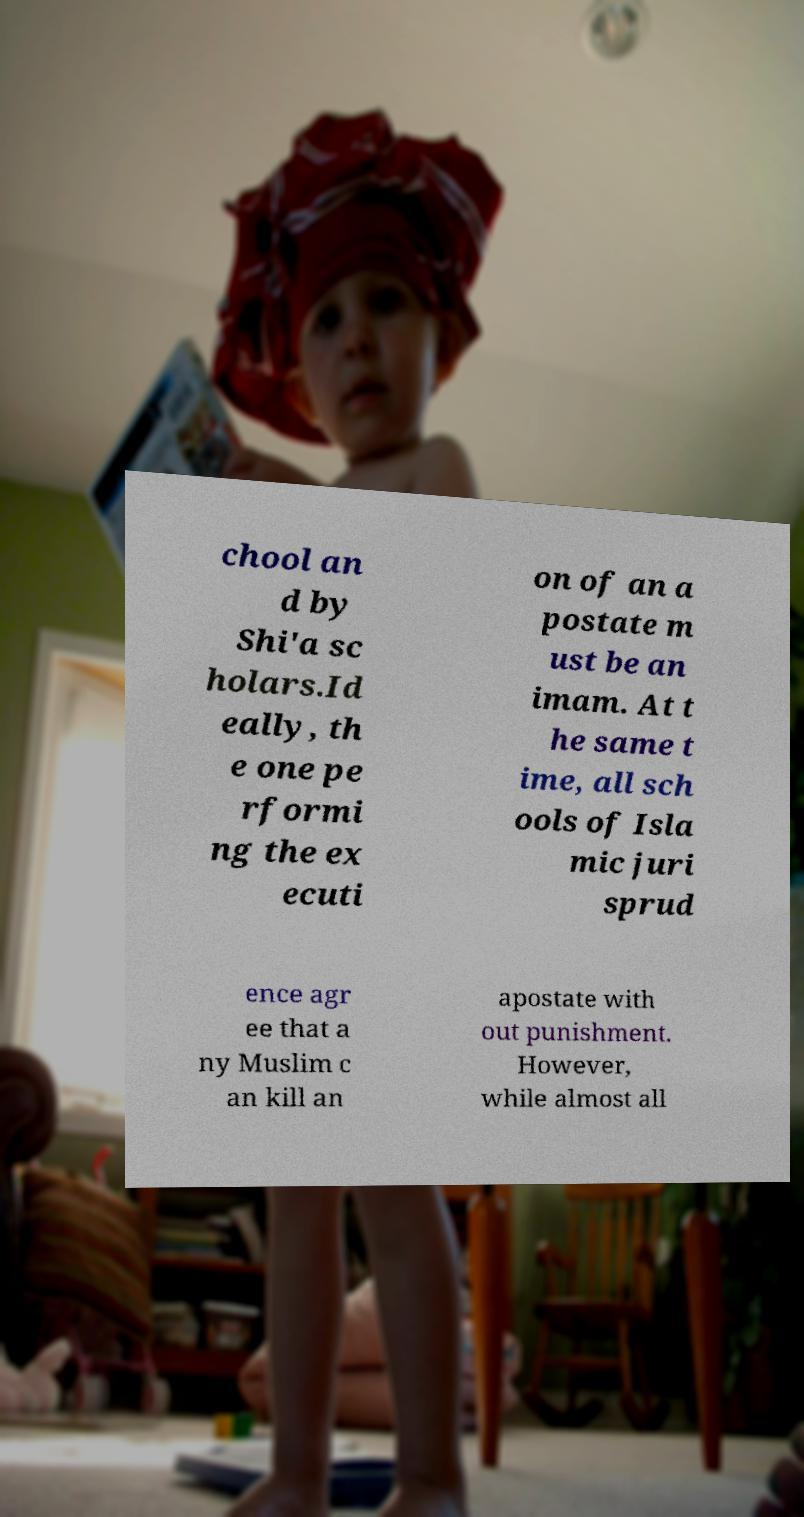What messages or text are displayed in this image? I need them in a readable, typed format. chool an d by Shi'a sc holars.Id eally, th e one pe rformi ng the ex ecuti on of an a postate m ust be an imam. At t he same t ime, all sch ools of Isla mic juri sprud ence agr ee that a ny Muslim c an kill an apostate with out punishment. However, while almost all 